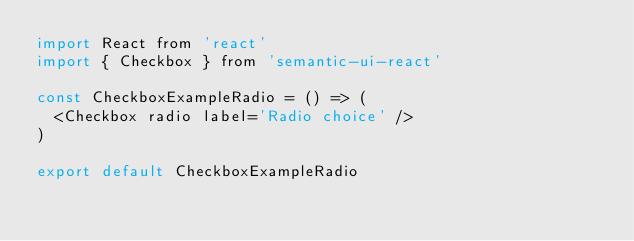Convert code to text. <code><loc_0><loc_0><loc_500><loc_500><_JavaScript_>import React from 'react'
import { Checkbox } from 'semantic-ui-react'

const CheckboxExampleRadio = () => (
  <Checkbox radio label='Radio choice' />
)

export default CheckboxExampleRadio
</code> 